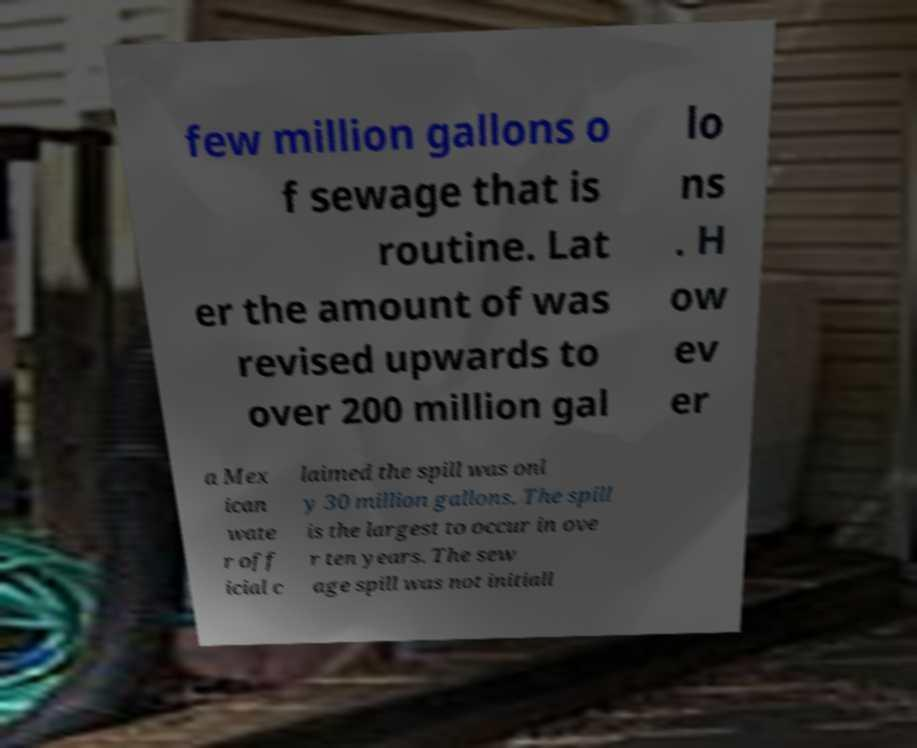Can you accurately transcribe the text from the provided image for me? few million gallons o f sewage that is routine. Lat er the amount of was revised upwards to over 200 million gal lo ns . H ow ev er a Mex ican wate r off icial c laimed the spill was onl y 30 million gallons. The spill is the largest to occur in ove r ten years. The sew age spill was not initiall 